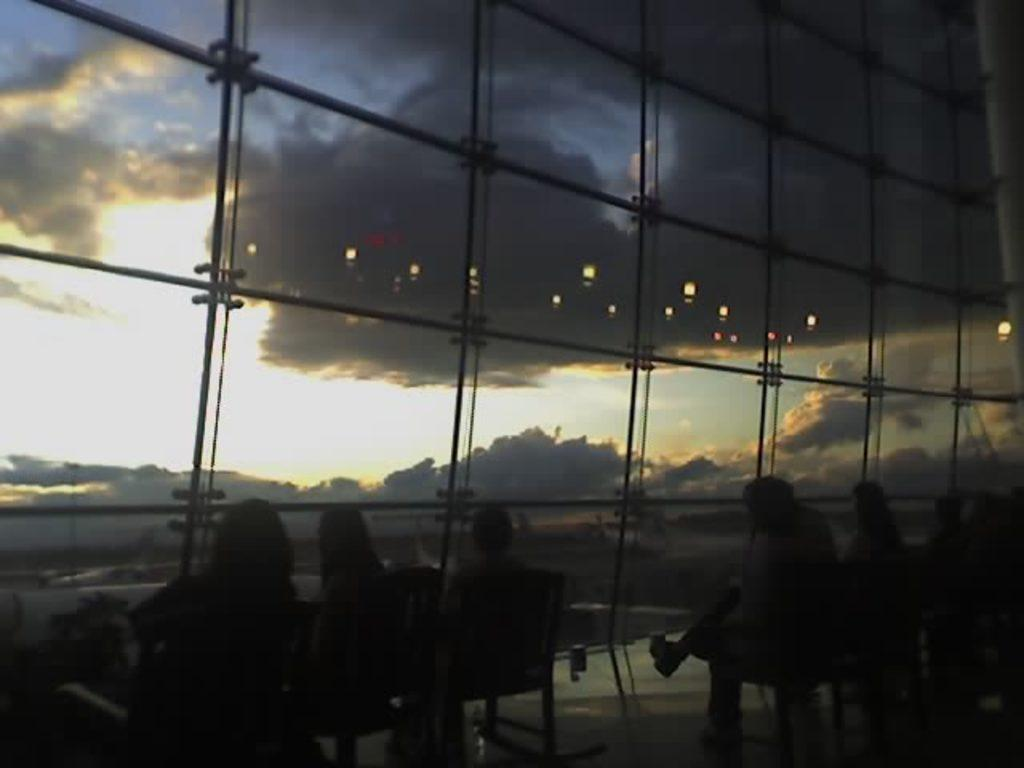What are the people in the image doing? The persons in the image are sitting on chairs in the foreground. What is the location of the chairs in relation to the glass wall? The chairs are near a glass wall. What can be seen in the background of the image? The sky and clouds are visible in the background of the image. What rhythm is the chair following in the image? Chairs do not have a rhythm; they are stationary objects. 